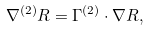Convert formula to latex. <formula><loc_0><loc_0><loc_500><loc_500>\nabla ^ { ( 2 ) } R = \Gamma ^ { ( 2 ) } \cdot \nabla R ,</formula> 